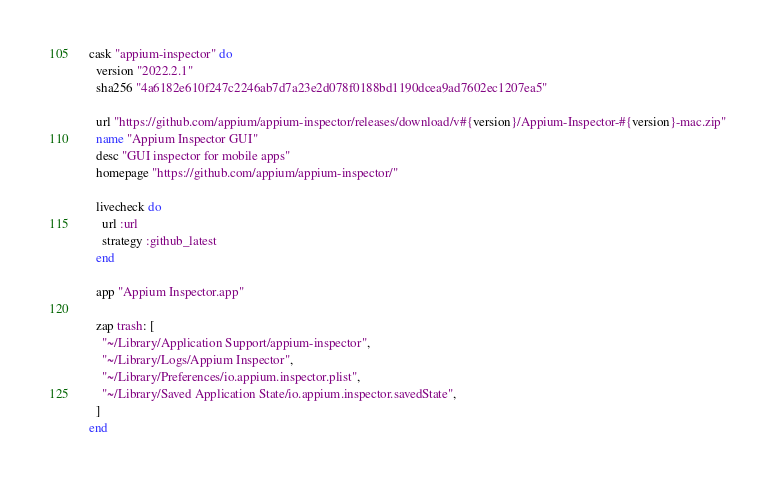Convert code to text. <code><loc_0><loc_0><loc_500><loc_500><_Ruby_>cask "appium-inspector" do
  version "2022.2.1"
  sha256 "4a6182e610f247c2246ab7d7a23e2d078f0188bd1190dcea9ad7602ec1207ea5"

  url "https://github.com/appium/appium-inspector/releases/download/v#{version}/Appium-Inspector-#{version}-mac.zip"
  name "Appium Inspector GUI"
  desc "GUI inspector for mobile apps"
  homepage "https://github.com/appium/appium-inspector/"

  livecheck do
    url :url
    strategy :github_latest
  end

  app "Appium Inspector.app"

  zap trash: [
    "~/Library/Application Support/appium-inspector",
    "~/Library/Logs/Appium Inspector",
    "~/Library/Preferences/io.appium.inspector.plist",
    "~/Library/Saved Application State/io.appium.inspector.savedState",
  ]
end
</code> 